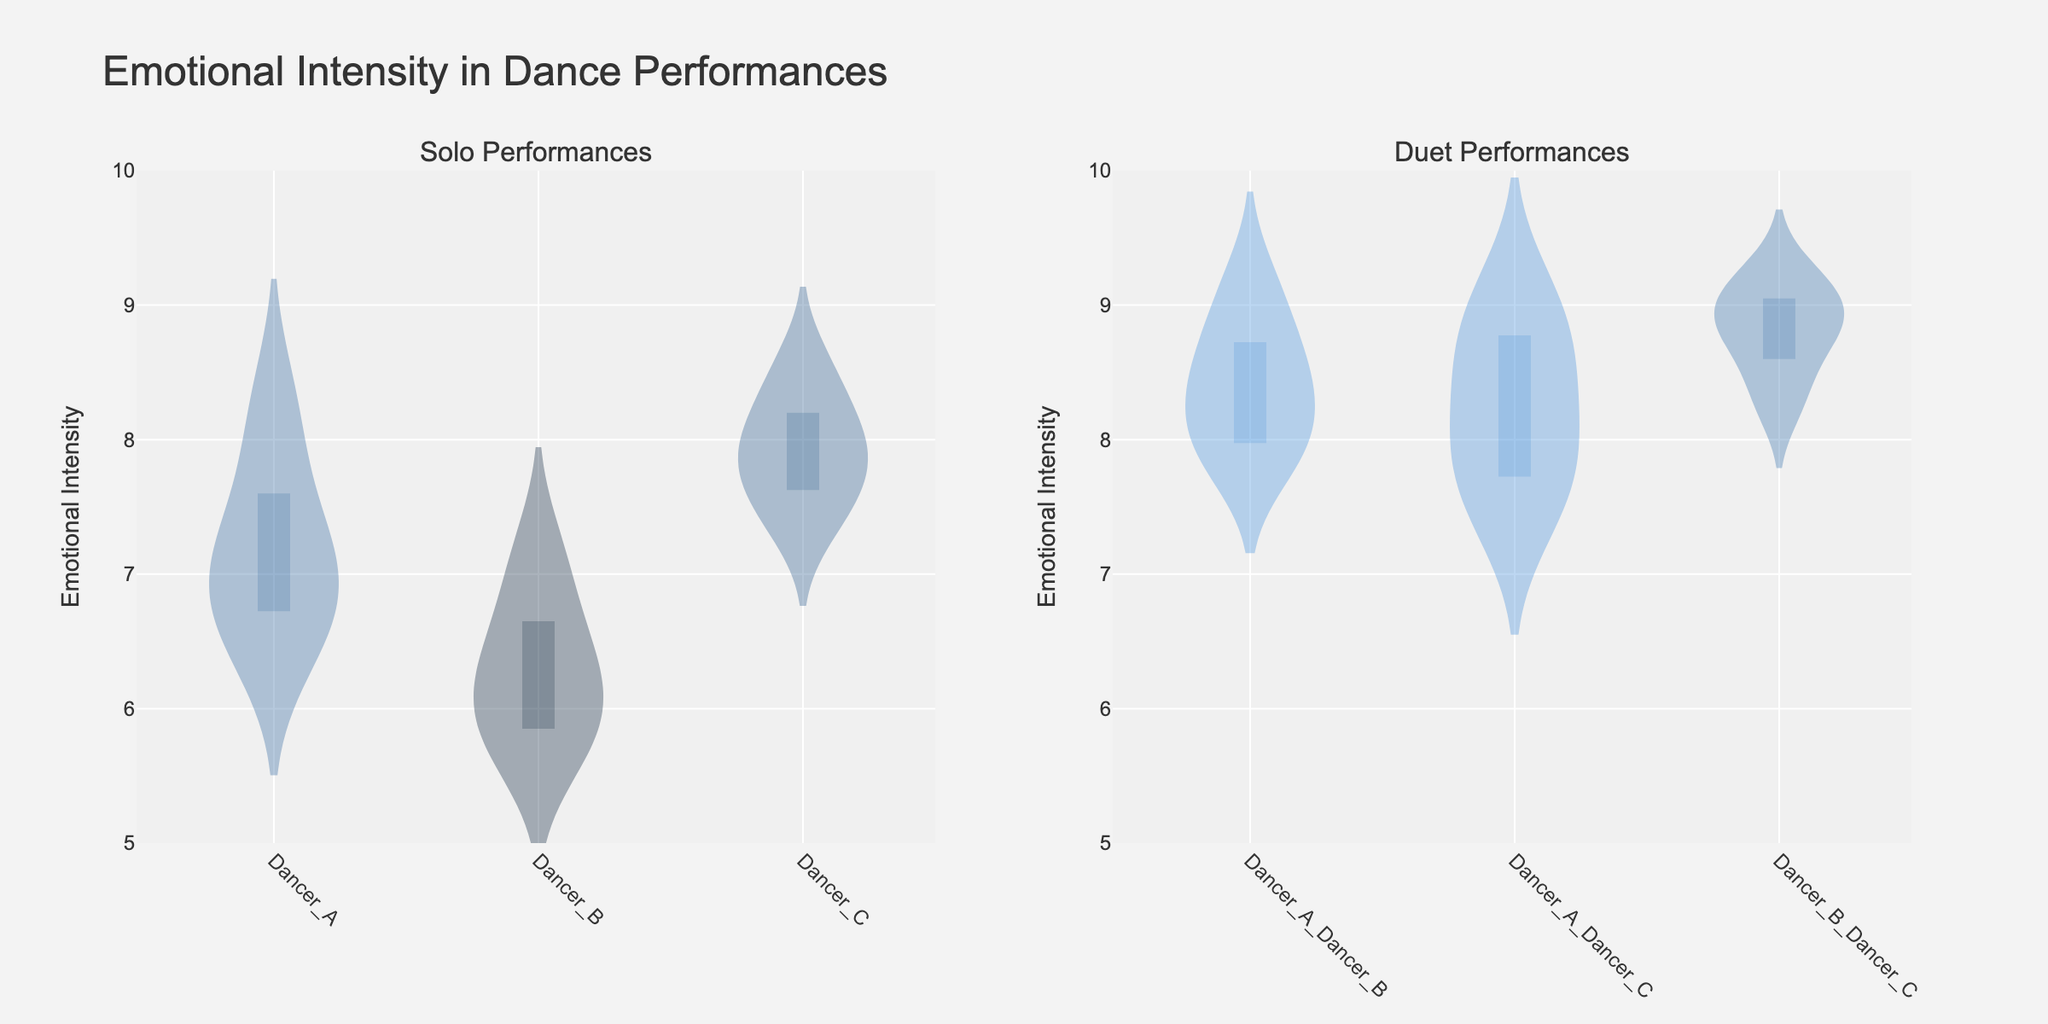What's the title of the figure? The title is displayed prominently at the top of the figure in a larger font than the rest of the text, designed to summarize the information presented.
Answer: Emotional Intensity in Dance Performances What is the y-axis range of the Emotional Intensity? The y-axis range can be determined by looking at the values listed along the y-axis, they go from the lowest to the highest point allowed on that axis.
Answer: 5 to 10 Which performance type has higher median Emotional Intensity: Solo or Duet? To find this, compare the median lines (often a dashed line) within each violin plot for the solo and duet subplots. The median of duet performances is consistently higher.
Answer: Duet How many unique types of performances are there? Each violin plot represents a unique type, and we count how many of these types exist in both the Solo and Duet subplots.
Answer: 6 (3 Solo types, 3 Duet types) What are the Emotional Intensity ratings for the duet of Dancer_A_Dancer_C? Identify the specific violin plot labeled Dancer_A_Dancer_C in the Duet subplot, and look at the spread of points within the plot.
Answer: 7.5, 8.7, 9.0, 8.2, 7.8 Which solo dancer has the highest observed Emotional Intensity rating? To determine this, find the peak point in the violin plots on the Solo subplot and identify which dancer it corresponds to. The highest point for solo dancers is observed in the Dancer_C plot.
Answer: Dancer_C Compare the mean Emotional Intensity of Dancer_A in Solo and Dancer_A_Dancer_B in Duet. Which one is higher? Locate the mean lines (often indicated by a darker dot or line) in the Dancer_A plot under Solo and in the Dancer_A_Dancer_B plot under Duet, then compare these two values.
Answer: Dancer_A_Dancer_B in Duet Is there a larger spread of Emotional Intensity ratings in the Solo or Duet performances? A larger spread will show a wider violin plot. Compare the overall width of all solo violin plots against all duet violin plots. The spreads in the Duet performances are consistently wider.
Answer: Duet What is the predominant color used for Dancer_B_Dancer_C duet plot? Examine the fill color of the violin plot labeled Dancer_B_Dancer_C in the Duet subplot. This can be inferred visually based on the plot's color representation.
Answer: Purple (approximation) Which duet performance type shows the tightest range of Emotional Intensity ratings? The tightest range will correspond to the narrowest violin plot, indicating less variability within those ratings. Compare the widths of the violin plots for all duet performance types.
Answer: Dancer_A_Dancer_C 